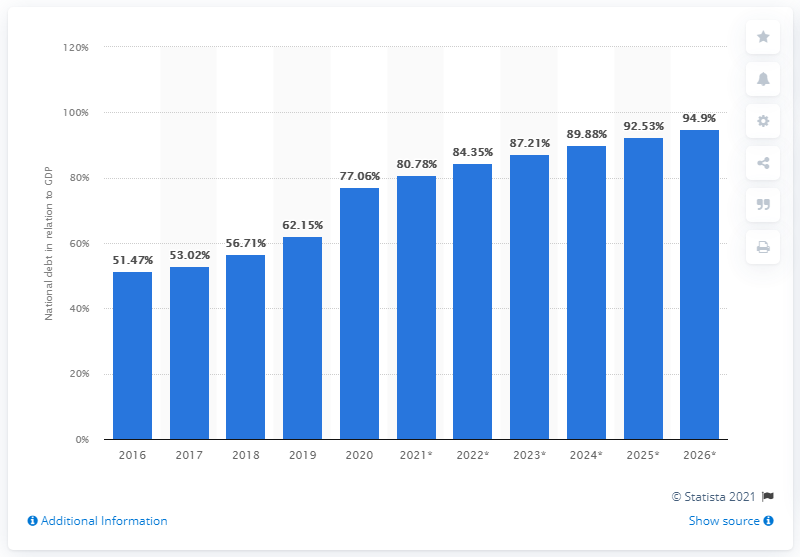Identify some key points in this picture. In the year 2020, the national debt of South Africa came to an end. In 2020, the national debt of South Africa accounted for approximately 77.06% of the country's Gross Domestic Product (GDP). 